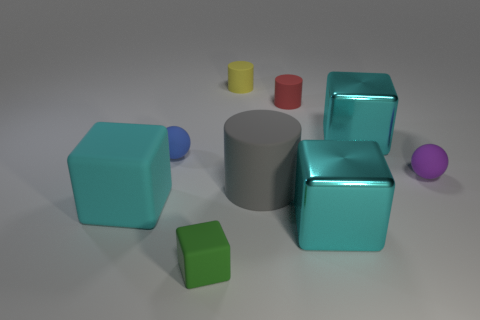Are any small matte things visible?
Your response must be concise. Yes. Is there any other thing that has the same shape as the yellow object?
Make the answer very short. Yes. Are there more matte balls on the right side of the small rubber cube than rubber cylinders?
Make the answer very short. No. There is a yellow cylinder; are there any small red cylinders right of it?
Provide a short and direct response. Yes. Do the red matte thing and the purple rubber sphere have the same size?
Your answer should be compact. Yes. What is the size of the gray rubber thing that is the same shape as the yellow thing?
Provide a succinct answer. Large. The small yellow thing that is left of the cyan metallic object that is in front of the purple matte ball is made of what material?
Your response must be concise. Rubber. Is the shape of the tiny red matte thing the same as the yellow object?
Your answer should be very brief. Yes. What number of big cyan things are both in front of the purple thing and right of the tiny blue object?
Ensure brevity in your answer.  1. Are there an equal number of tiny purple matte balls that are in front of the big cylinder and yellow rubber things that are in front of the small green matte cube?
Keep it short and to the point. Yes. 